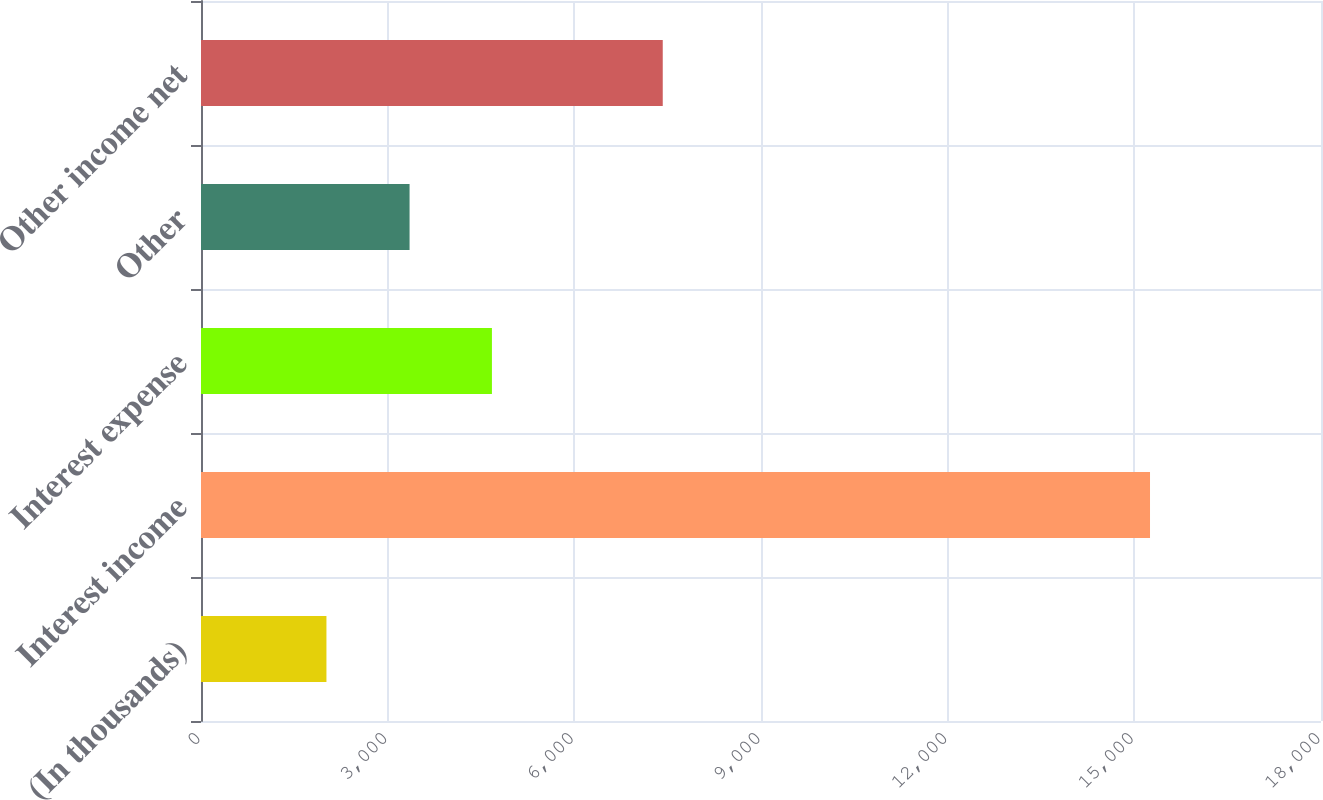<chart> <loc_0><loc_0><loc_500><loc_500><bar_chart><fcel>(In thousands)<fcel>Interest income<fcel>Interest expense<fcel>Other<fcel>Other income net<nl><fcel>2016<fcel>15252<fcel>4675.6<fcel>3352<fcel>7421<nl></chart> 